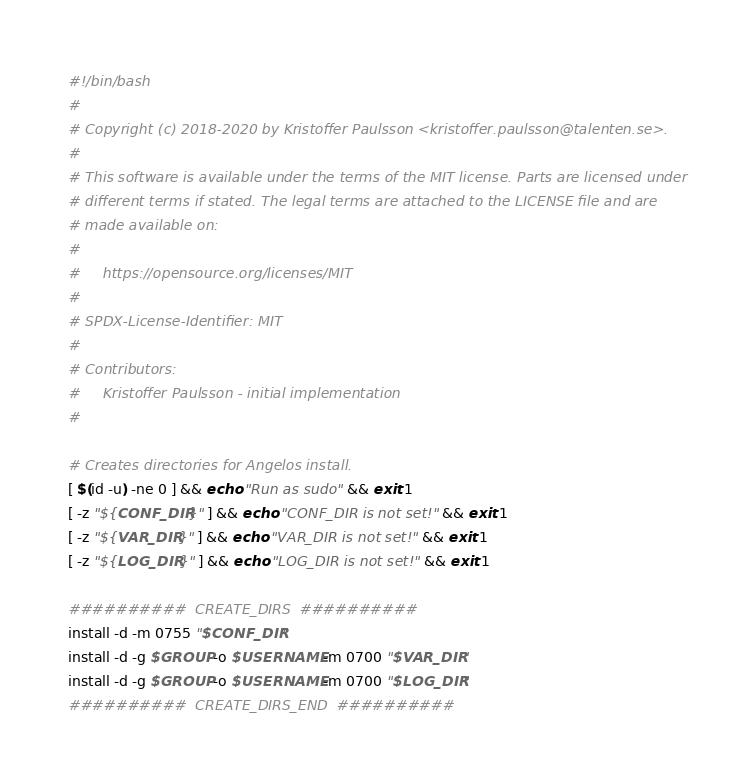<code> <loc_0><loc_0><loc_500><loc_500><_Bash_>#!/bin/bash
#
# Copyright (c) 2018-2020 by Kristoffer Paulsson <kristoffer.paulsson@talenten.se>.
#
# This software is available under the terms of the MIT license. Parts are licensed under
# different terms if stated. The legal terms are attached to the LICENSE file and are
# made available on:
#
#     https://opensource.org/licenses/MIT
#
# SPDX-License-Identifier: MIT
#
# Contributors:
#     Kristoffer Paulsson - initial implementation
#

# Creates directories for Angelos install.
[ $(id -u) -ne 0 ] && echo "Run as sudo" && exit 1
[ -z "${CONF_DIR}" ] && echo "CONF_DIR is not set!" && exit 1
[ -z "${VAR_DIR}" ] && echo "VAR_DIR is not set!" && exit 1
[ -z "${LOG_DIR}" ] && echo "LOG_DIR is not set!" && exit 1

##########  CREATE_DIRS  ##########
install -d -m 0755 "$CONF_DIR"
install -d -g $GROUP -o $USERNAME -m 0700 "$VAR_DIR"
install -d -g $GROUP -o $USERNAME -m 0700 "$LOG_DIR"
##########  CREATE_DIRS_END  ##########</code> 